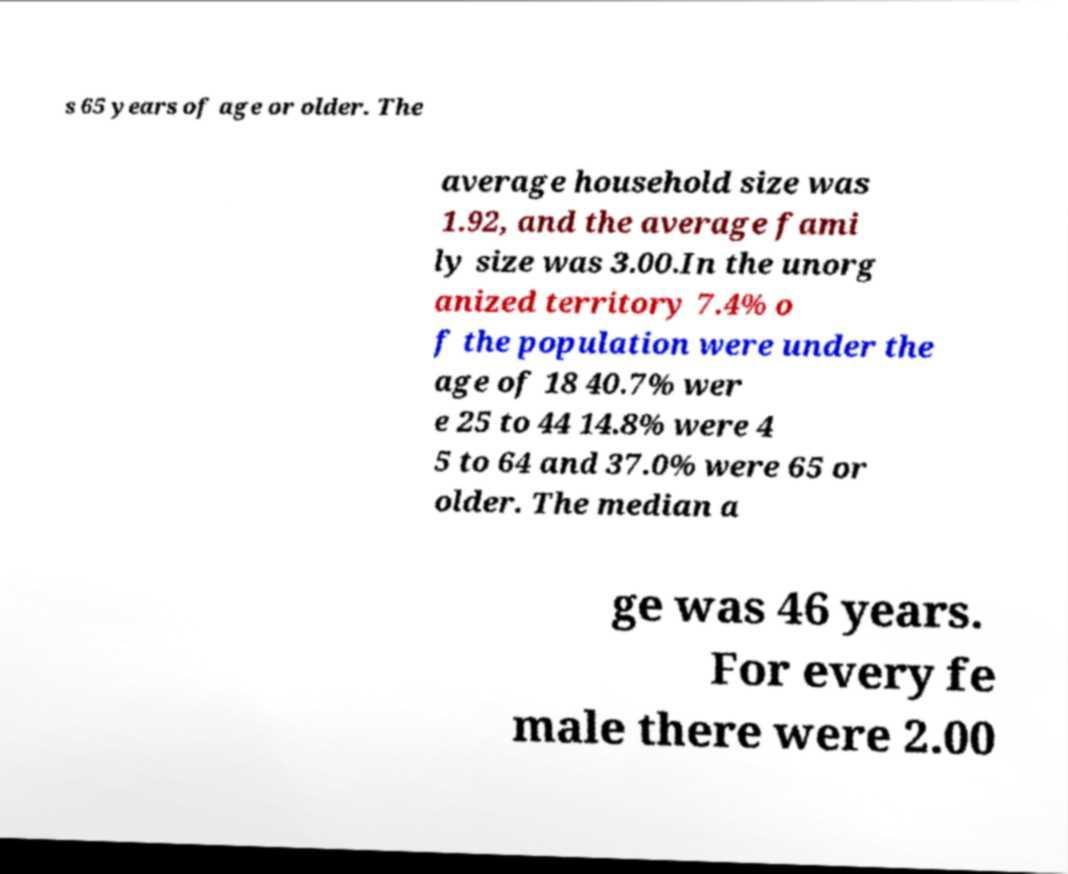Please identify and transcribe the text found in this image. s 65 years of age or older. The average household size was 1.92, and the average fami ly size was 3.00.In the unorg anized territory 7.4% o f the population were under the age of 18 40.7% wer e 25 to 44 14.8% were 4 5 to 64 and 37.0% were 65 or older. The median a ge was 46 years. For every fe male there were 2.00 